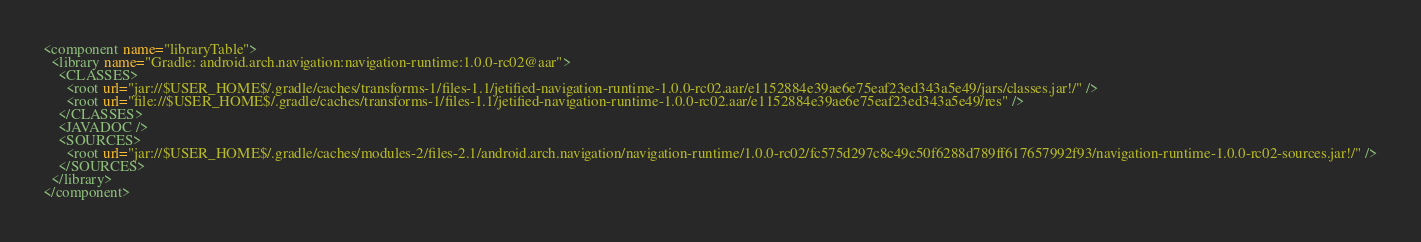Convert code to text. <code><loc_0><loc_0><loc_500><loc_500><_XML_><component name="libraryTable">
  <library name="Gradle: android.arch.navigation:navigation-runtime:1.0.0-rc02@aar">
    <CLASSES>
      <root url="jar://$USER_HOME$/.gradle/caches/transforms-1/files-1.1/jetified-navigation-runtime-1.0.0-rc02.aar/e1152884e39ae6e75eaf23ed343a5e49/jars/classes.jar!/" />
      <root url="file://$USER_HOME$/.gradle/caches/transforms-1/files-1.1/jetified-navigation-runtime-1.0.0-rc02.aar/e1152884e39ae6e75eaf23ed343a5e49/res" />
    </CLASSES>
    <JAVADOC />
    <SOURCES>
      <root url="jar://$USER_HOME$/.gradle/caches/modules-2/files-2.1/android.arch.navigation/navigation-runtime/1.0.0-rc02/fc575d297c8c49c50f6288d789ff617657992f93/navigation-runtime-1.0.0-rc02-sources.jar!/" />
    </SOURCES>
  </library>
</component></code> 